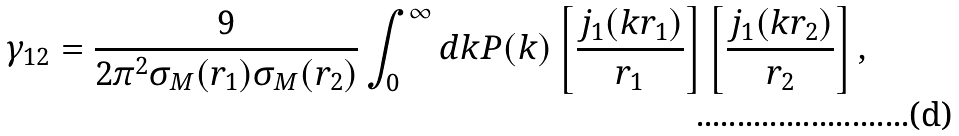Convert formula to latex. <formula><loc_0><loc_0><loc_500><loc_500>\gamma _ { 1 2 } = \frac { 9 } { 2 \pi ^ { 2 } \sigma _ { M } ( r _ { 1 } ) \sigma _ { M } ( r _ { 2 } ) } \int _ { 0 } ^ { \infty } d k P ( k ) \left [ \frac { j _ { 1 } ( k r _ { 1 } ) } { r _ { 1 } } \right ] \left [ \frac { j _ { 1 } ( k r _ { 2 } ) } { r _ { 2 } } \right ] ,</formula> 